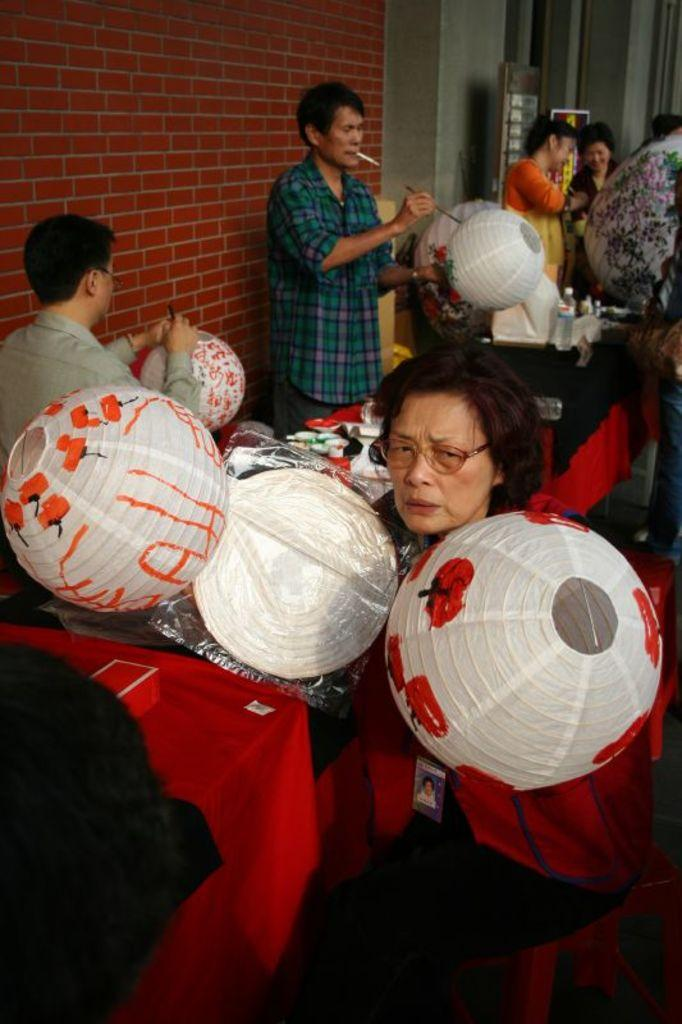How many people are present in the image? There are many people in the image. What are the people holding in the image? The people are holding balloons. Can you describe the table in the image? There is a table with a red cloth in the image. What can be seen in the background of the image? There is a wall in the background of the image. What type of pancake is being served on the table in the image? There is no pancake present in the image; it features people holding balloons and a table with a red cloth. How many books are visible on the wall in the image? There are no books visible on the wall in the image; it only shows a wall in the background. 